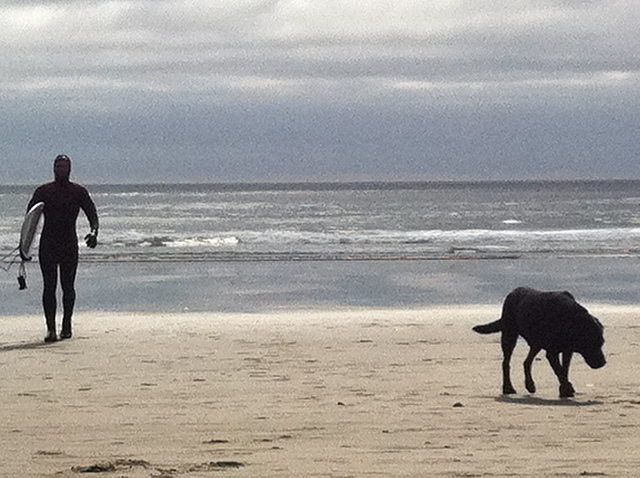<image>What color is the collar? I am not sure about the color of the collar. It can be black or there may be no collar. What color is the collar? I don't know what color the collar is. It can be black or there might not be a collar. 